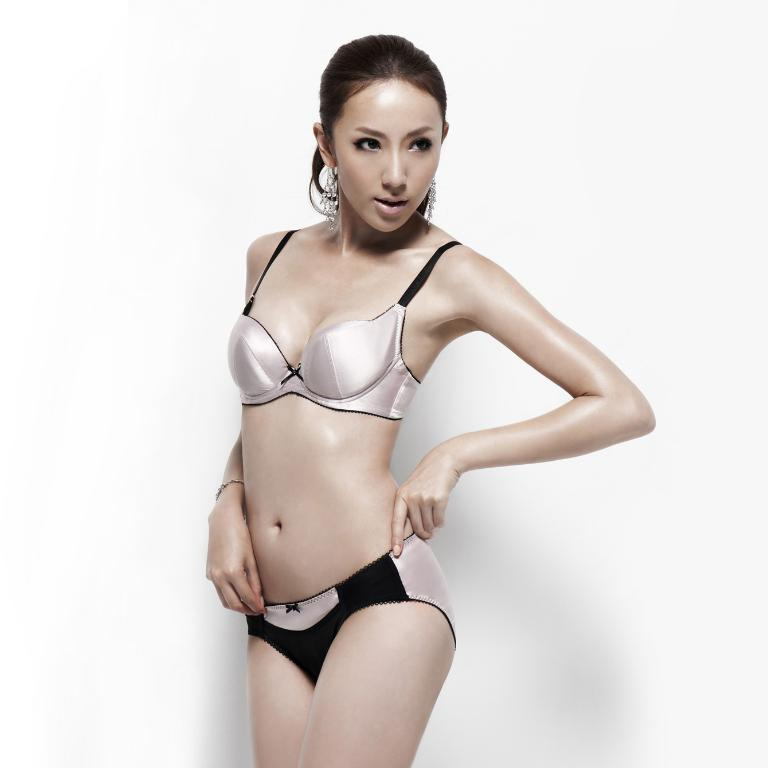What is the main subject of the image? There is a beautiful woman in the image. What is the woman doing in the image? The woman is standing. What type of clothing is the woman wearing on her upper body? The woman is wearing a top. What type of clothing is the woman wearing around her waist? The woman is wearing waist clothes. How many babies are visible in the image? There are no babies present in the image; it features a beautiful woman. What type of cream is being applied to the woman's face in the image? There is no cream being applied to the woman's face in the image. 